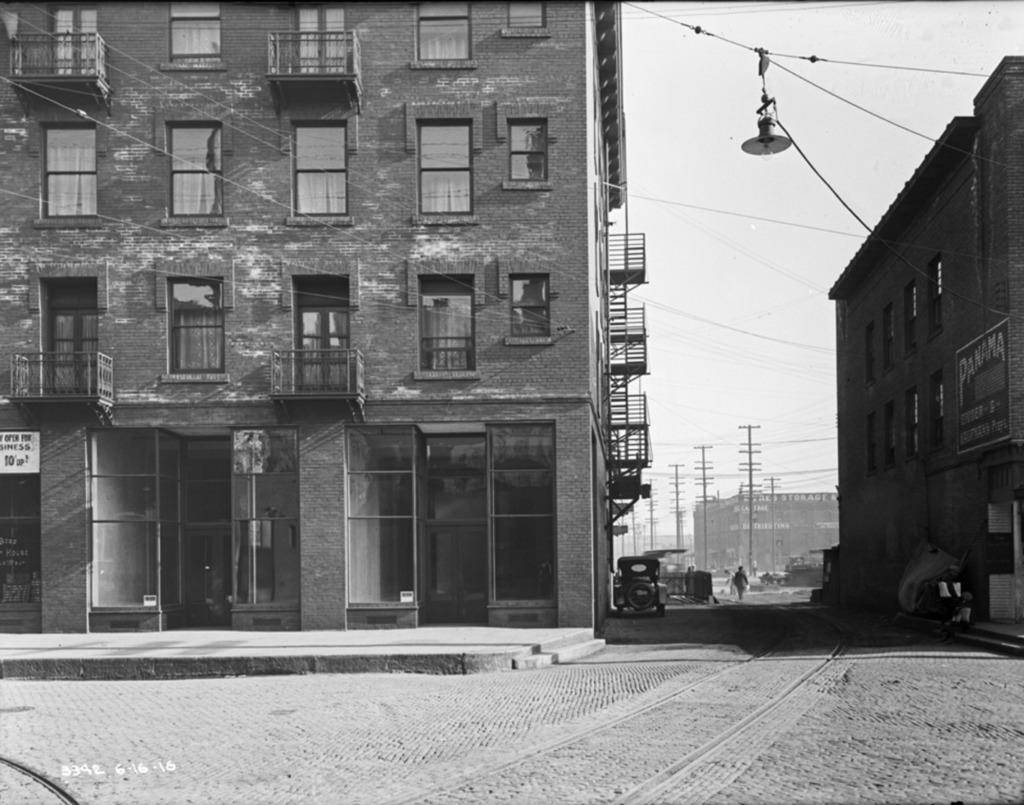What type of structures are visible in the image? There are buildings in the image. What features can be seen on the buildings? The buildings have windows and grills. What else can be seen in the image besides the buildings? There are poles and a lamp hanged on a wire in the image. What type of sweater is being knitted with the yarn in the image? There is no sweater or yarn present in the image; it features buildings with windows and grills, poles, and a lamp on a wire. 